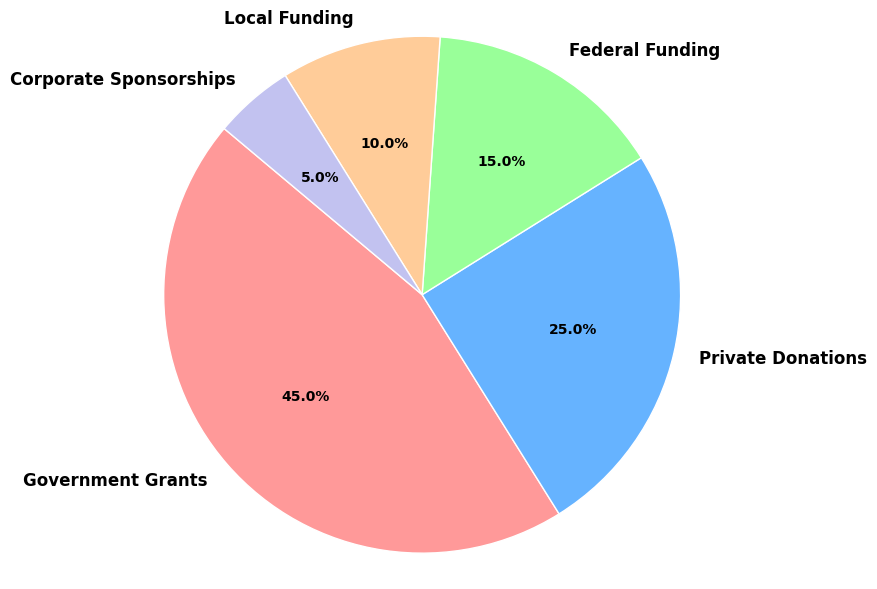What is the largest funding source for social services programs? To find the largest funding source, look at the percentages of each category in the pie chart. The segment representing 45% is the largest, which corresponds to Government Grants.
Answer: Government Grants What is the combined percentage of Private Donations and Local Funding? Add the percentages for Private Donations and Local Funding. Private Donations make up 25% and Local Funding makes up 10%. The total is 25% + 10% = 35%.
Answer: 35% Which funding source is the smallest? To identify the smallest funding source, find the segment of the pie chart with the smallest percentage. Corporate Sponsorships is the smallest with 5%.
Answer: Corporate Sponsorships How much more percentage does Government Grants contribute compared to Federal Funding? Calculate the difference in percentage between Government Grants and Federal Funding. Government Grants contribute 45% and Federal Funding contributes 15%. The difference is 45% - 15% = 30%.
Answer: 30% Are there any funding sources that contribute an equal percentage? Check if any two or more segments in the pie chart have the same percentage value. All segments have unique percentages according to the data provided.
Answer: No Compare the contribution of Private Donations to Local Funding. Which one is greater and by how much? Private Donations contribute 25%, while Local Funding contributes 10%. The difference is 25% - 10% = 15%. Therefore, Private Donations contribute more by 15%.
Answer: Private Donations by 15% What is the total percentage contribution of all funding sources other than Government Grants? Sum the percentages of all funding sources except for Government Grants. These are: Private Donations (25%), Federal Funding (15%), Local Funding (10%), and Corporate Sponsorships (5%). The total is 25% + 15% + 10% + 5% = 55%.
Answer: 55% What color represents Federal Funding, and what percentage does it contribute? Identify the color representing Federal Funding on the pie chart. Federal Funding is shown in green, and it contributes 15%.
Answer: Green, 15% If Government Grants were reduced by half, what would be the new percentage value for this source? Halve the percentage value of Government Grants. The current percentage is 45%, so the new percentage would be 45% / 2 = 22.5%.
Answer: 22.5% Is the total percentage of all the segments in the pie chart equal to 100%? Sum the percentages of all the segments. The percentages are: 45%, 25%, 15%, 10%, and 5%. The total is 45% + 25% + 15% + 10% + 5% = 100%.
Answer: Yes 